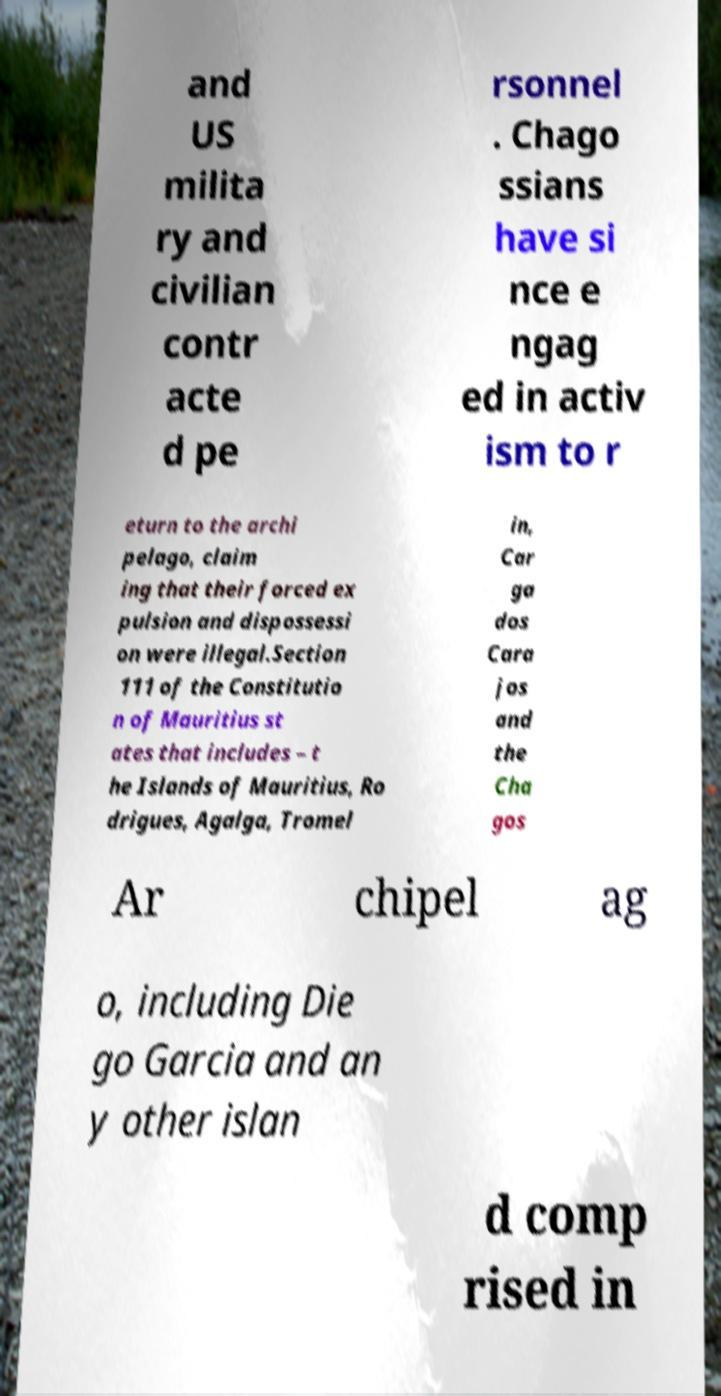Could you extract and type out the text from this image? and US milita ry and civilian contr acte d pe rsonnel . Chago ssians have si nce e ngag ed in activ ism to r eturn to the archi pelago, claim ing that their forced ex pulsion and dispossessi on were illegal.Section 111 of the Constitutio n of Mauritius st ates that includes – t he Islands of Mauritius, Ro drigues, Agalga, Tromel in, Car ga dos Cara jos and the Cha gos Ar chipel ag o, including Die go Garcia and an y other islan d comp rised in 